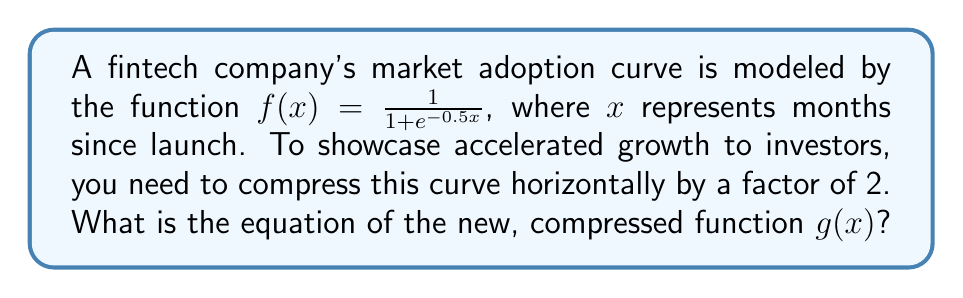Solve this math problem. To horizontally compress a function by a factor of $k$, we replace $x$ with $kx$ in the original function. In this case, we want to compress by a factor of 2, so $k = 2$.

Starting with the original function:
$$f(x) = \frac{1}{1 + e^{-0.5x}}$$

To create the compressed function $g(x)$, we replace $x$ with $2x$:
$$g(x) = f(2x) = \frac{1}{1 + e^{-0.5(2x)}}$$

Simplifying the exponent:
$$g(x) = \frac{1}{1 + e^{-x}}$$

This new function $g(x)$ represents the horizontally compressed version of the original market adoption curve. It will reach the same adoption levels in half the time, effectively showing accelerated growth to potential investors.

[asy]
import graph;
size(200,150);
real f(real x) {return 1/(1+exp(-0.5x));}
real g(real x) {return 1/(1+exp(-x));}
draw(graph(f,-2,10),blue,Arrows);
draw(graph(g,-2,10),red,Arrows);
xaxis("x (months)",arrow=Arrow);
yaxis("Adoption",arrow=Arrow);
label("$f(x)$",(8,f(8)),NW,blue);
label("$g(x)$",(4,g(4)),NW,red);
[/asy]
Answer: $g(x) = \frac{1}{1 + e^{-x}}$ 